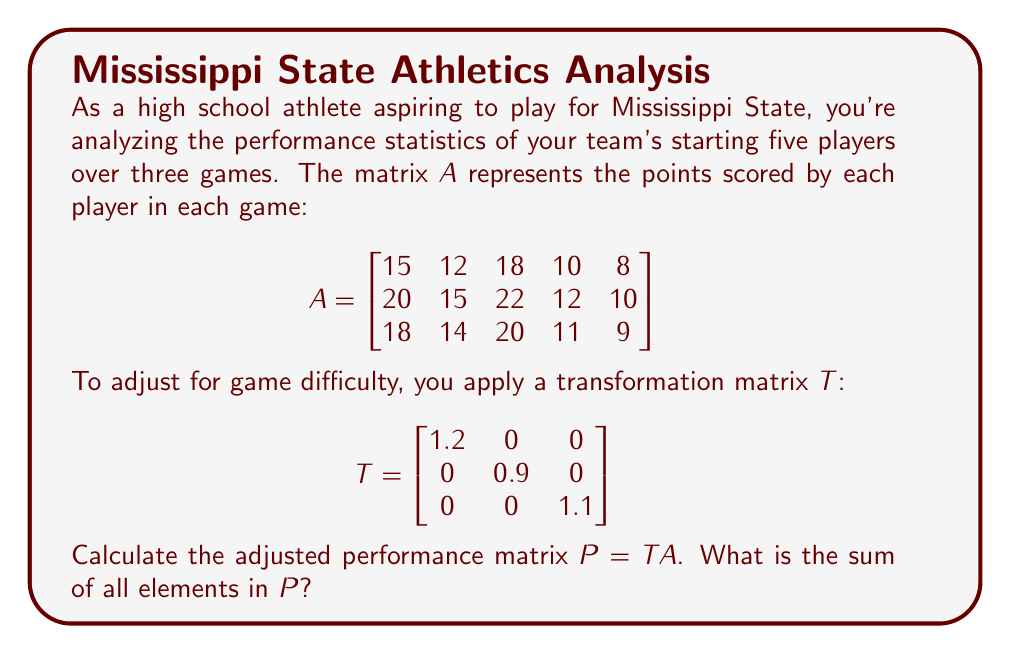Show me your answer to this math problem. Let's approach this step-by-step:

1) First, we need to multiply matrices $T$ and $A$. The resulting matrix $P$ will have the same dimensions as $A$ (3x5).

2) To perform matrix multiplication, we multiply each row of $T$ with each column of $A$:

   $$P = \begin{bmatrix}
   1.2(15) & 1.2(12) & 1.2(18) & 1.2(10) & 1.2(8) \\
   0.9(20) & 0.9(15) & 0.9(22) & 0.9(12) & 0.9(10) \\
   1.1(18) & 1.1(14) & 1.1(20) & 1.1(11) & 1.1(9)
   \end{bmatrix}$$

3) Calculating each element:

   $$P = \begin{bmatrix}
   18 & 14.4 & 21.6 & 12 & 9.6 \\
   18 & 13.5 & 19.8 & 10.8 & 9 \\
   19.8 & 15.4 & 22 & 12.1 & 9.9
   \end{bmatrix}$$

4) To find the sum of all elements, we add up every number in the matrix:

   $18 + 14.4 + 21.6 + 12 + 9.6 + 18 + 13.5 + 19.8 + 10.8 + 9 + 19.8 + 15.4 + 22 + 12.1 + 9.9$

5) Adding these up: $225.9$
Answer: 225.9 